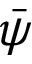<formula> <loc_0><loc_0><loc_500><loc_500>\bar { \psi }</formula> 